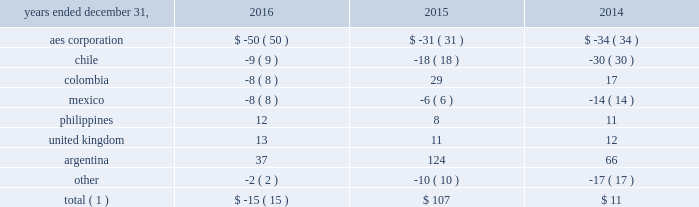The net decrease in the 2016 effective tax rate was due , in part , to the 2016 asset impairments in the u.s .
And to the current year benefit related to a restructuring of one of our brazilian businesses that increases tax basis in long-term assets .
Further , the 2015 rate was impacted by the items described below .
See note 20 2014asset impairment expense for additional information regarding the 2016 u.s .
Asset impairments .
Income tax expense increased $ 101 million , or 27% ( 27 % ) , to $ 472 million in 2015 .
The company's effective tax rates were 41% ( 41 % ) and 26% ( 26 % ) for the years ended december 31 , 2015 and 2014 , respectively .
The net increase in the 2015 effective tax rate was due , in part , to the nondeductible 2015 impairment of goodwill at our u.s .
Utility , dp&l and chilean withholding taxes offset by the release of valuation allowance at certain of our businesses in brazil , vietnam and the u.s .
Further , the 2014 rate was impacted by the sale of approximately 45% ( 45 % ) of the company 2019s interest in masin aes pte ltd. , which owns the company 2019s business interests in the philippines and the 2014 sale of the company 2019s interests in four u.k .
Wind operating projects .
Neither of these transactions gave rise to income tax expense .
See note 15 2014equity for additional information regarding the sale of approximately 45% ( 45 % ) of the company 2019s interest in masin-aes pte ltd .
See note 23 2014dispositions for additional information regarding the sale of the company 2019s interests in four u.k .
Wind operating projects .
Our effective tax rate reflects the tax effect of significant operations outside the u.s. , which are generally taxed at rates lower than the u.s .
Statutory rate of 35% ( 35 % ) .
A future proportionate change in the composition of income before income taxes from foreign and domestic tax jurisdictions could impact our periodic effective tax rate .
The company also benefits from reduced tax rates in certain countries as a result of satisfying specific commitments regarding employment and capital investment .
See note 21 2014income taxes for additional information regarding these reduced rates .
Foreign currency transaction gains ( losses ) foreign currency transaction gains ( losses ) in millions were as follows: .
Total ( 1 ) $ ( 15 ) $ 107 $ 11 _____________________________ ( 1 ) includes gains of $ 17 million , $ 247 million and $ 172 million on foreign currency derivative contracts for the years ended december 31 , 2016 , 2015 and 2014 , respectively .
The company recognized a net foreign currency transaction loss of $ 15 million for the year ended december 31 , 2016 primarily due to losses of $ 50 million at the aes corporation mainly due to remeasurement losses on intercompany notes , and losses on swaps and options .
This loss was partially offset by gains of $ 37 million in argentina , mainly due to the favorable impact of foreign currency derivatives related to government receivables .
The company recognized a net foreign currency transaction gain of $ 107 million for the year ended december 31 , 2015 primarily due to gains of : 2022 $ 124 million in argentina , due to the favorable impact from foreign currency derivatives related to government receivables , partially offset by losses from the devaluation of the argentine peso associated with u.s .
Dollar denominated debt , and losses at termoandes ( a u.s .
Dollar functional currency subsidiary ) primarily associated with cash and accounts receivable balances in local currency , 2022 $ 29 million in colombia , mainly due to the depreciation of the colombian peso , positively impacting chivor ( a u.s .
Dollar functional currency subsidiary ) due to liabilities denominated in colombian pesos , 2022 $ 11 million in the united kingdom , mainly due to the depreciation of the pound sterling , resulting in gains at ballylumford holdings ( a u.s .
Dollar functional currency subsidiary ) associated with intercompany notes payable denominated in pound sterling , and .
What was the maximum argentina foreign currency gains in millions fofr the three year period? 
Computations: table_max(argentina, none)
Answer: 124.0. 